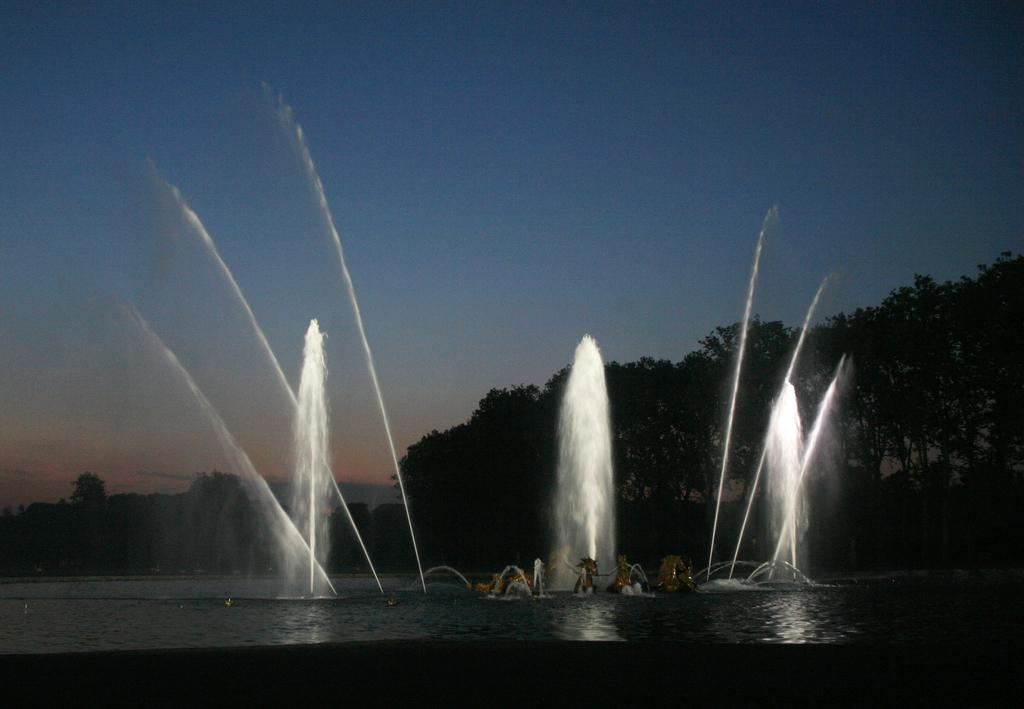What is visible in the image? Water, statues, trees, and the sky are visible in the image. Can you describe the statues in the image? There are statues in the image, but their specific details are not mentioned in the provided facts. What type of natural environment is depicted in the image? The image features a natural environment with water, trees, and the sky visible. What is visible in the background of the image? The sky is visible in the background of the image. Where is the cobweb located in the image? There is no cobweb present in the image. What type of train can be seen passing by in the image? There is no train present in the image. 